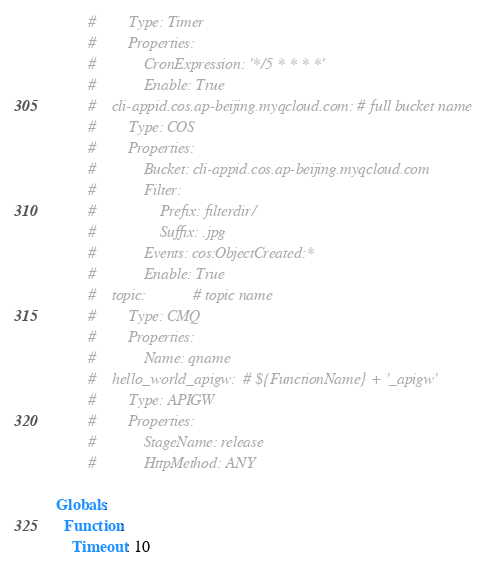<code> <loc_0><loc_0><loc_500><loc_500><_YAML_>        #        Type: Timer
        #        Properties:
        #            CronExpression: '*/5 * * * *'
        #            Enable: True
        #    cli-appid.cos.ap-beijing.myqcloud.com: # full bucket name
        #        Type: COS
        #        Properties:
        #            Bucket: cli-appid.cos.ap-beijing.myqcloud.com
        #            Filter:
        #                Prefix: filterdir/
        #                Suffix: .jpg
        #            Events: cos:ObjectCreated:*
        #            Enable: True
        #    topic:            # topic name
        #        Type: CMQ
        #        Properties:
        #            Name: qname
        #    hello_world_apigw:  # ${FunctionName} + '_apigw'
        #        Type: APIGW
        #        Properties:
        #            StageName: release
        #            HttpMethod: ANY

Globals:
  Function:
    Timeout: 10
</code> 